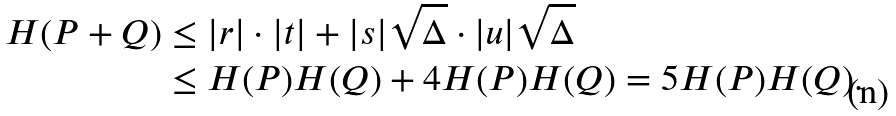Convert formula to latex. <formula><loc_0><loc_0><loc_500><loc_500>H ( P + Q ) & \leq | r | \cdot | t | + | s | \sqrt { \Delta } \cdot | u | \sqrt { \Delta } \\ & \leq H ( P ) H ( Q ) + 4 H ( P ) H ( Q ) = 5 H ( P ) H ( Q ) .</formula> 